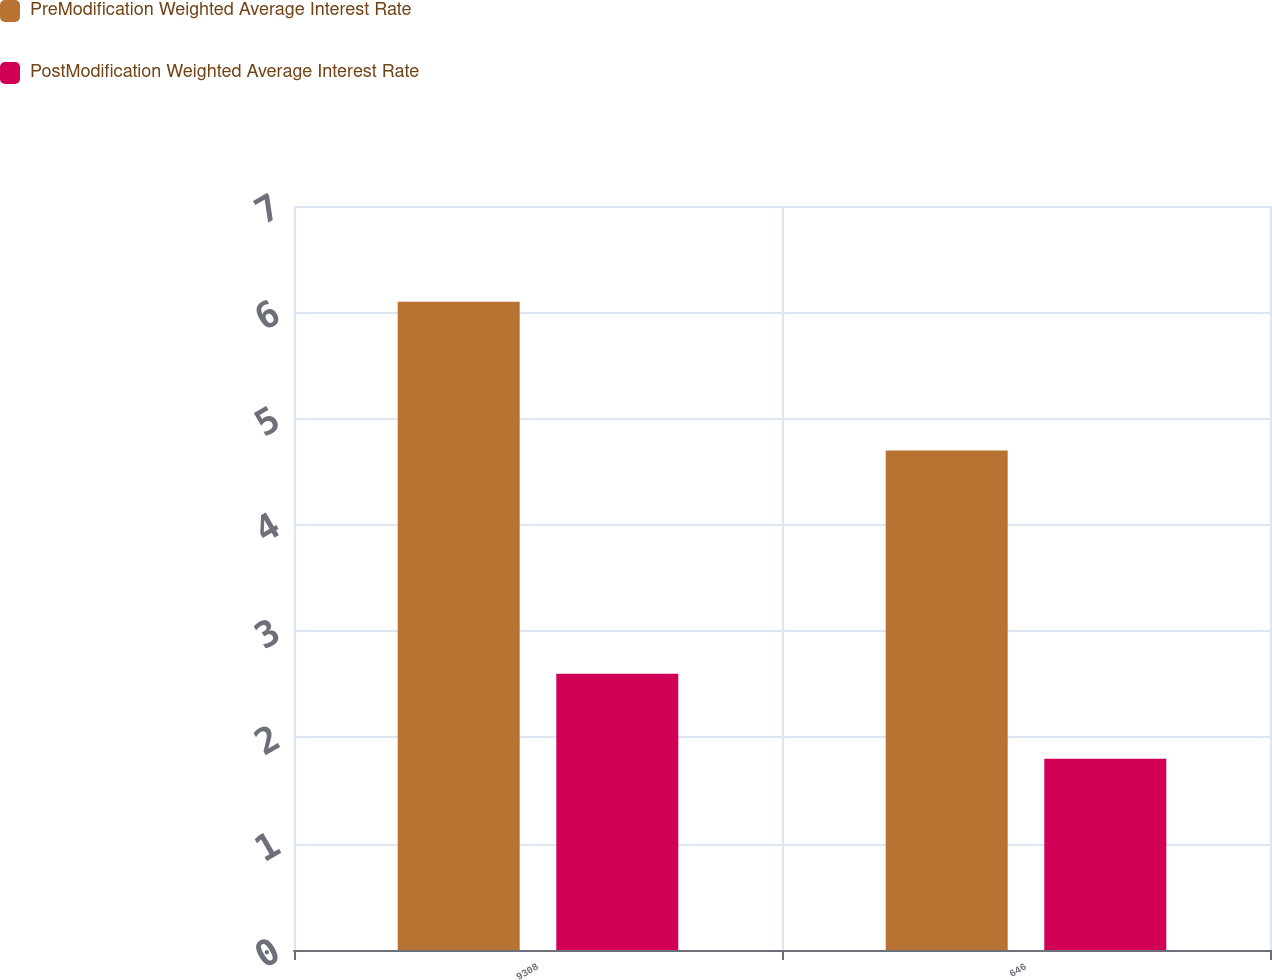Convert chart to OTSL. <chart><loc_0><loc_0><loc_500><loc_500><stacked_bar_chart><ecel><fcel>9308<fcel>646<nl><fcel>PreModification Weighted Average Interest Rate<fcel>6.1<fcel>4.7<nl><fcel>PostModification Weighted Average Interest Rate<fcel>2.6<fcel>1.8<nl></chart> 